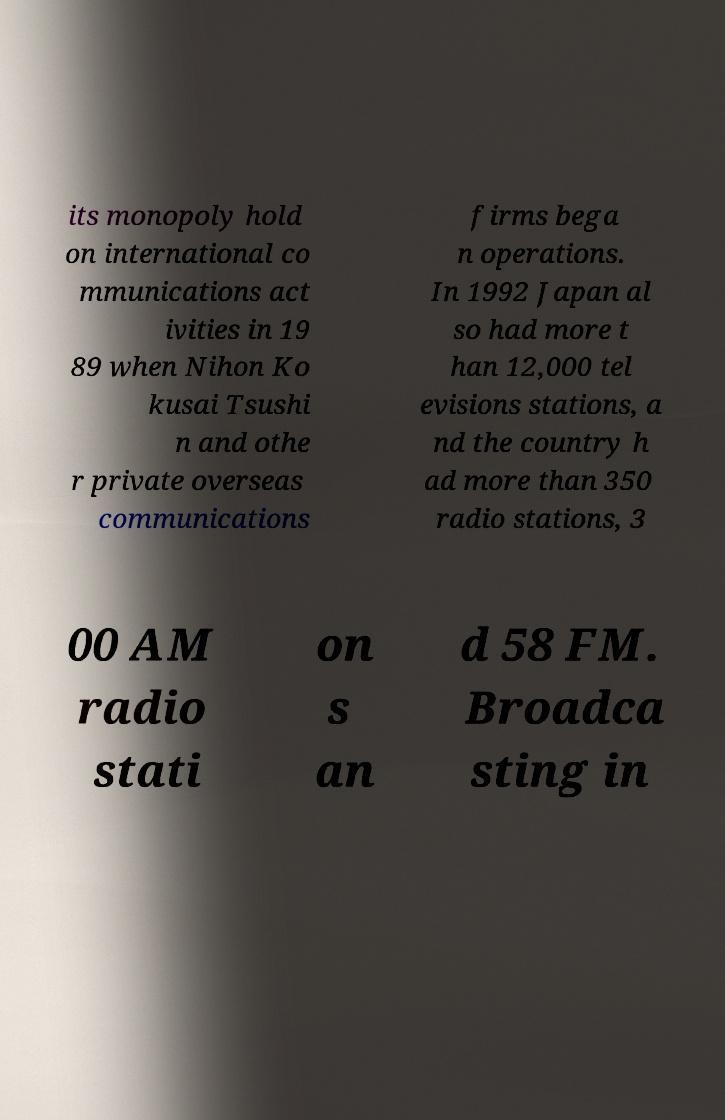Can you accurately transcribe the text from the provided image for me? its monopoly hold on international co mmunications act ivities in 19 89 when Nihon Ko kusai Tsushi n and othe r private overseas communications firms bega n operations. In 1992 Japan al so had more t han 12,000 tel evisions stations, a nd the country h ad more than 350 radio stations, 3 00 AM radio stati on s an d 58 FM. Broadca sting in 